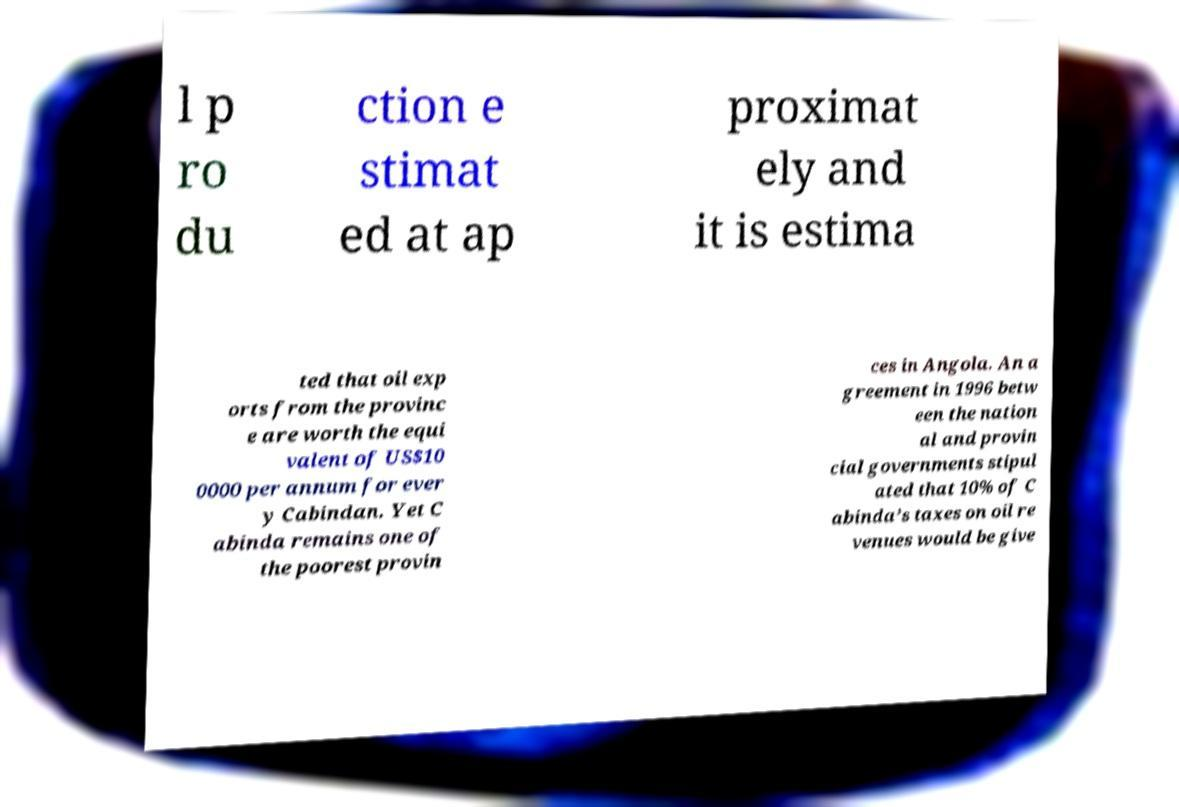What messages or text are displayed in this image? I need them in a readable, typed format. l p ro du ction e stimat ed at ap proximat ely and it is estima ted that oil exp orts from the provinc e are worth the equi valent of US$10 0000 per annum for ever y Cabindan. Yet C abinda remains one of the poorest provin ces in Angola. An a greement in 1996 betw een the nation al and provin cial governments stipul ated that 10% of C abinda’s taxes on oil re venues would be give 